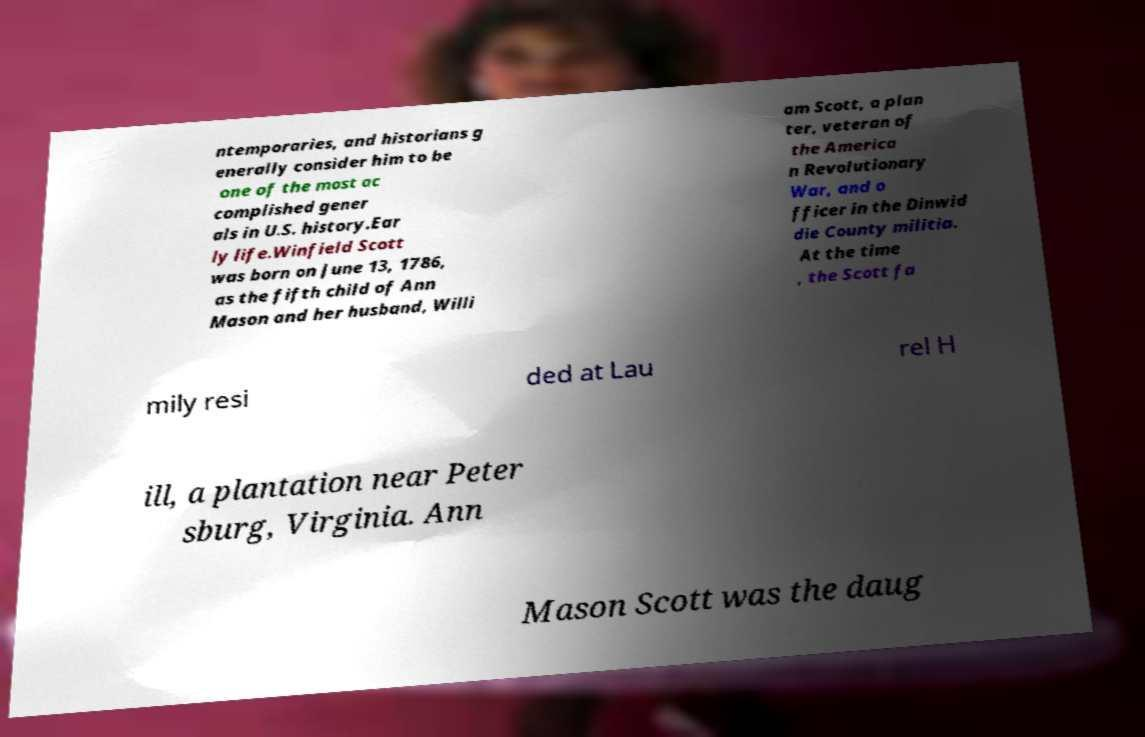I need the written content from this picture converted into text. Can you do that? ntemporaries, and historians g enerally consider him to be one of the most ac complished gener als in U.S. history.Ear ly life.Winfield Scott was born on June 13, 1786, as the fifth child of Ann Mason and her husband, Willi am Scott, a plan ter, veteran of the America n Revolutionary War, and o fficer in the Dinwid die County militia. At the time , the Scott fa mily resi ded at Lau rel H ill, a plantation near Peter sburg, Virginia. Ann Mason Scott was the daug 